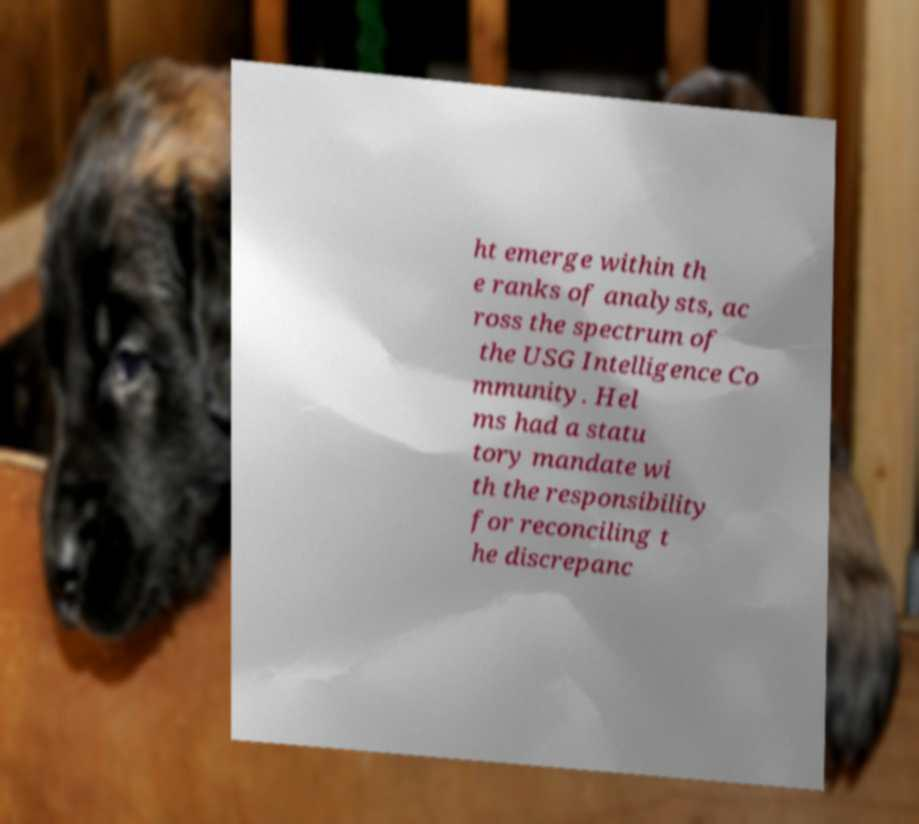I need the written content from this picture converted into text. Can you do that? ht emerge within th e ranks of analysts, ac ross the spectrum of the USG Intelligence Co mmunity. Hel ms had a statu tory mandate wi th the responsibility for reconciling t he discrepanc 